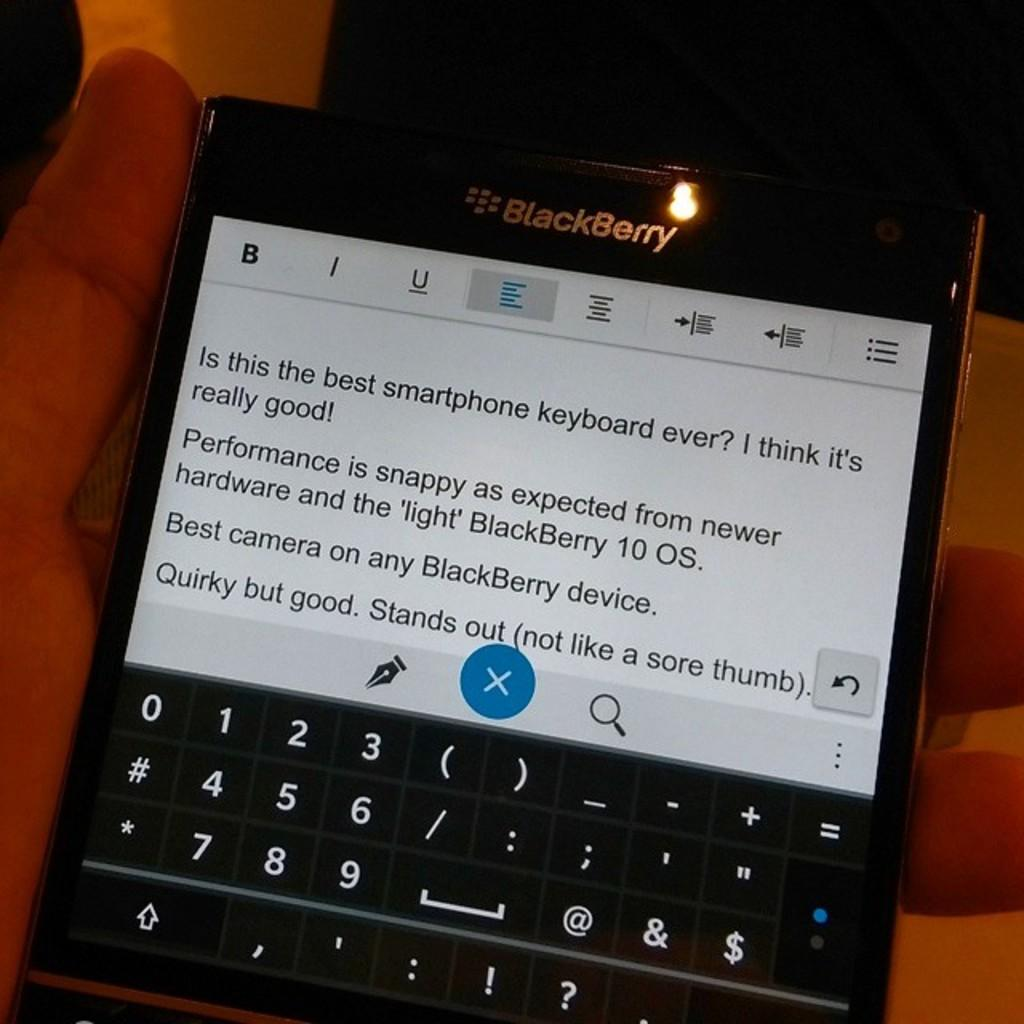<image>
Offer a succinct explanation of the picture presented. A BlackBerry phone claims to have "best camera on any BlackBerry device" 